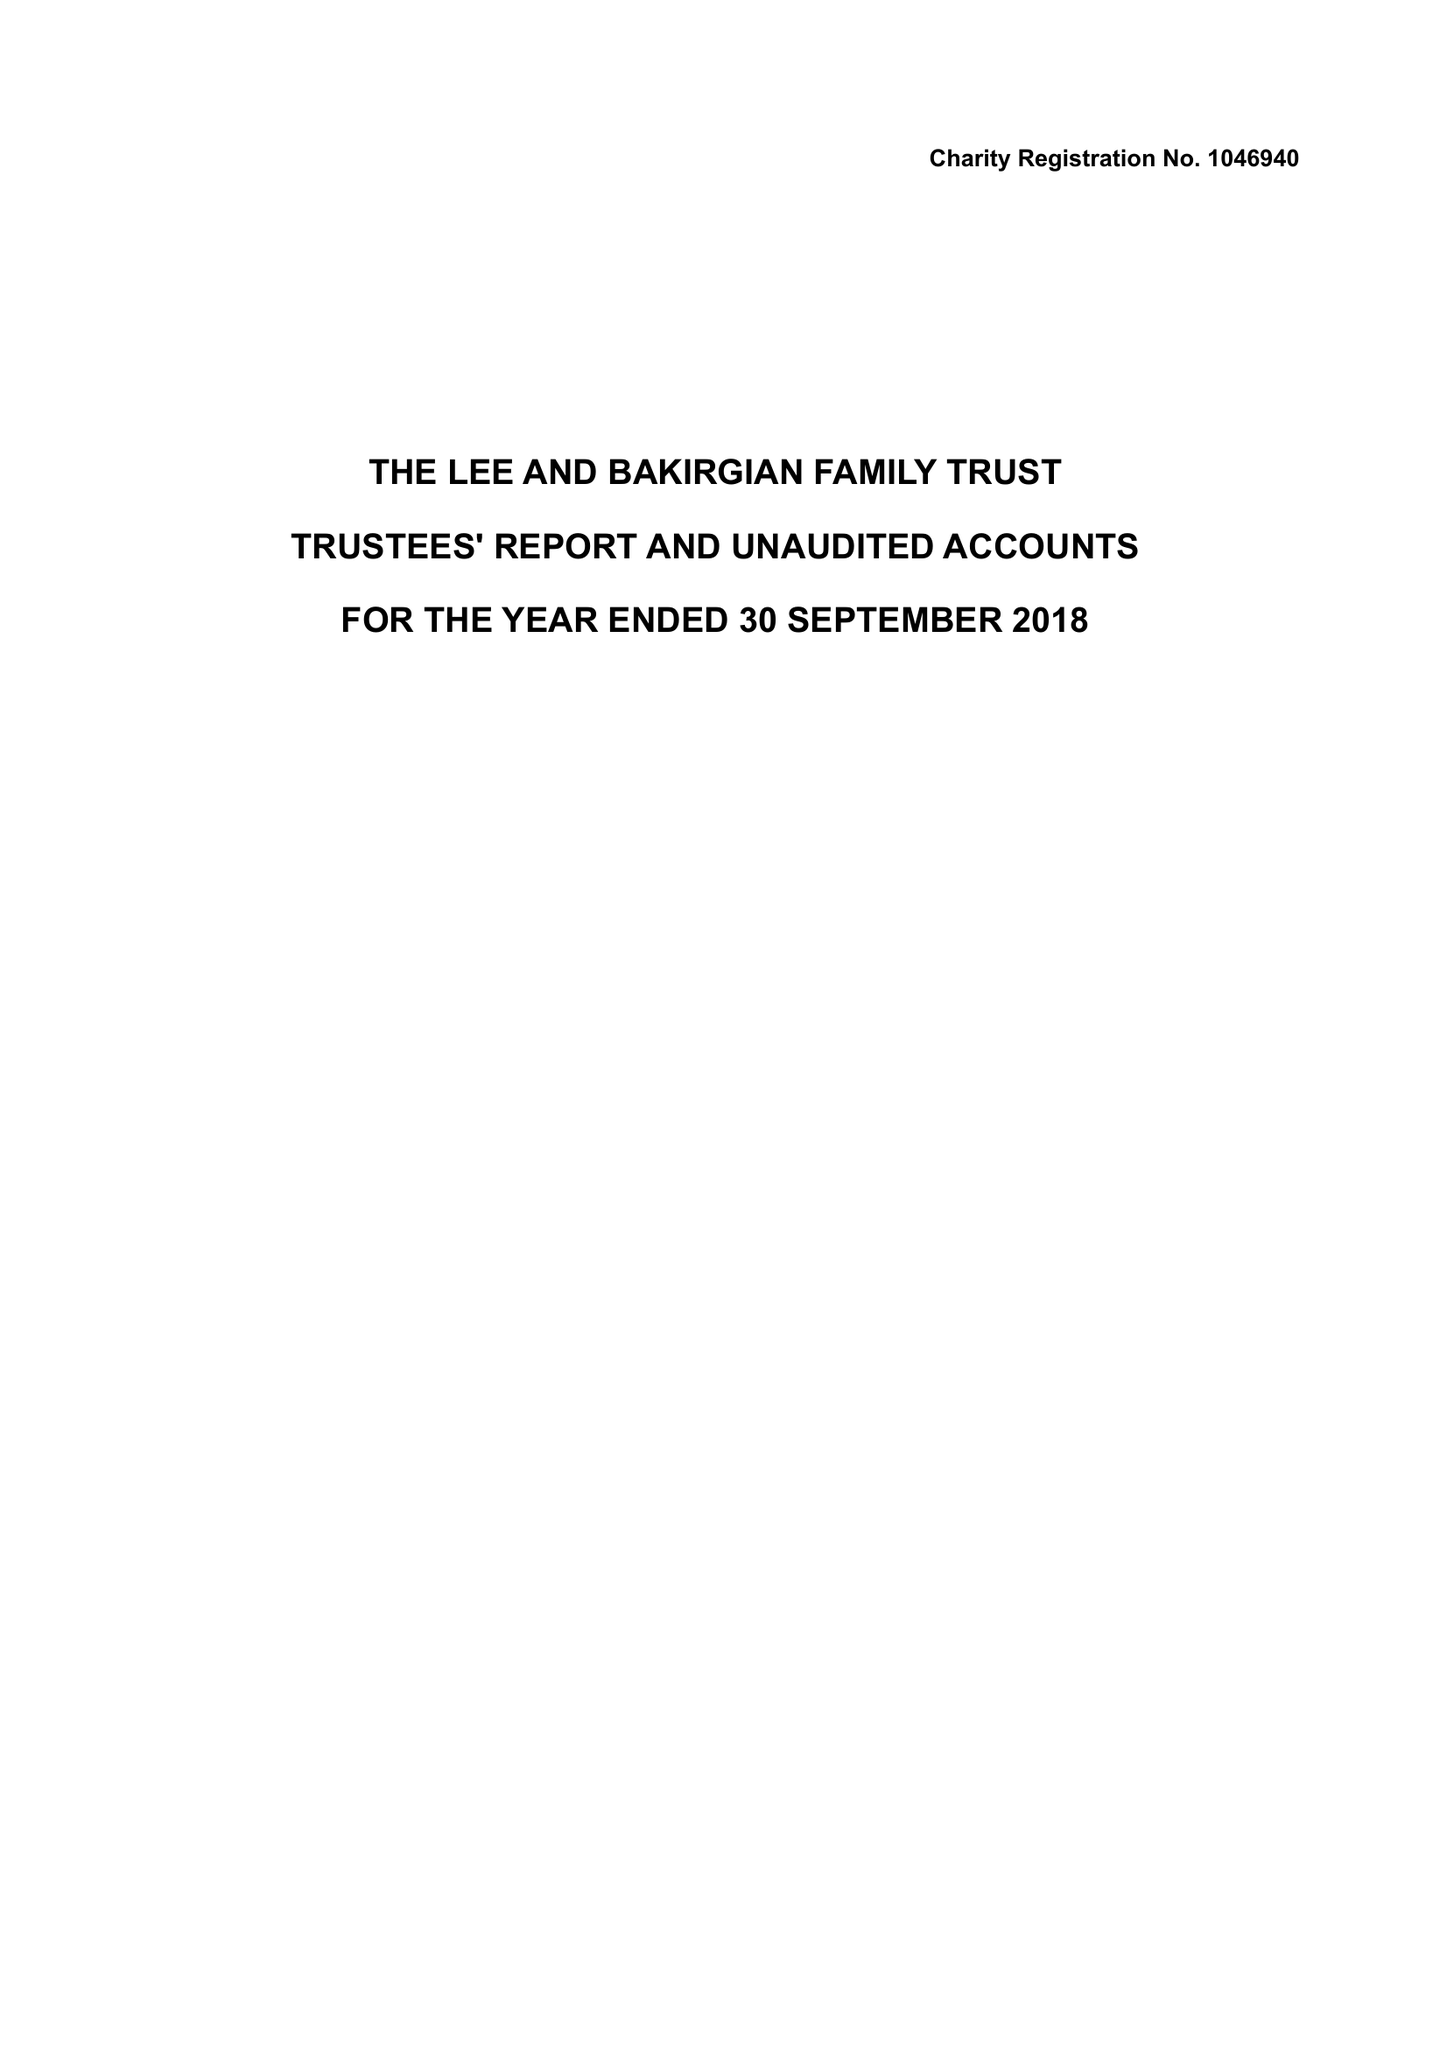What is the value for the charity_number?
Answer the question using a single word or phrase. 1046940 